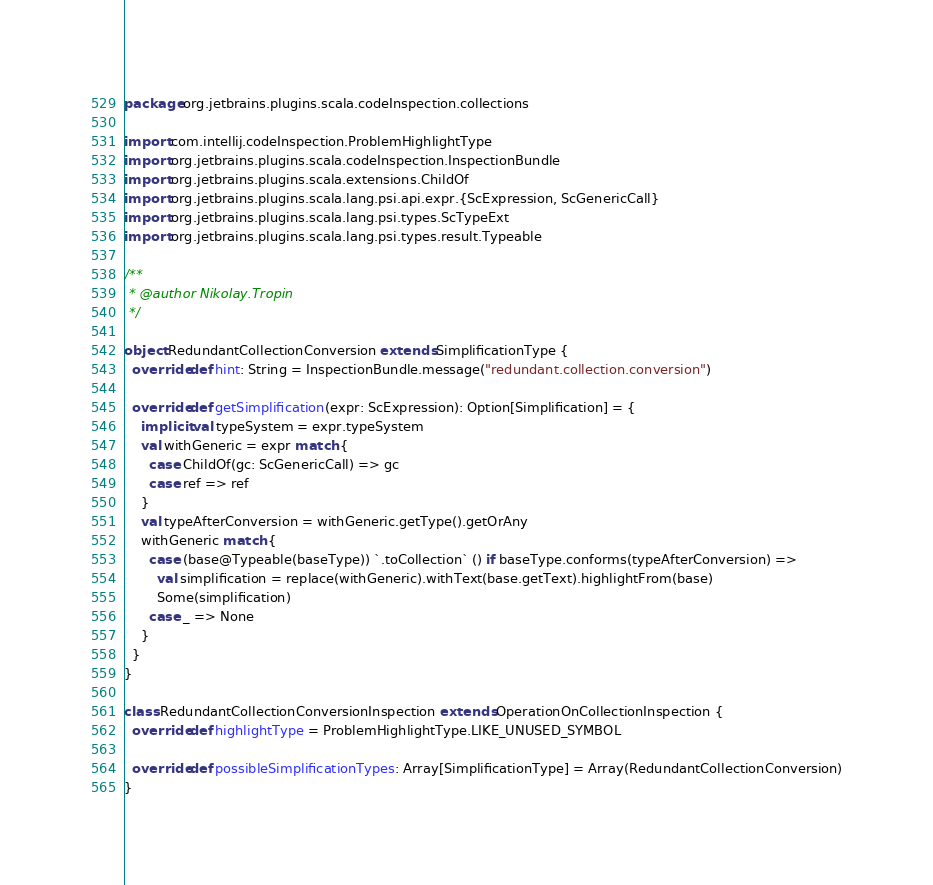Convert code to text. <code><loc_0><loc_0><loc_500><loc_500><_Scala_>package org.jetbrains.plugins.scala.codeInspection.collections

import com.intellij.codeInspection.ProblemHighlightType
import org.jetbrains.plugins.scala.codeInspection.InspectionBundle
import org.jetbrains.plugins.scala.extensions.ChildOf
import org.jetbrains.plugins.scala.lang.psi.api.expr.{ScExpression, ScGenericCall}
import org.jetbrains.plugins.scala.lang.psi.types.ScTypeExt
import org.jetbrains.plugins.scala.lang.psi.types.result.Typeable

/**
 * @author Nikolay.Tropin
 */

object RedundantCollectionConversion extends SimplificationType {
  override def hint: String = InspectionBundle.message("redundant.collection.conversion")

  override def getSimplification(expr: ScExpression): Option[Simplification] = {
    implicit val typeSystem = expr.typeSystem
    val withGeneric = expr match {
      case ChildOf(gc: ScGenericCall) => gc
      case ref => ref
    }
    val typeAfterConversion = withGeneric.getType().getOrAny
    withGeneric match {
      case (base@Typeable(baseType)) `.toCollection` () if baseType.conforms(typeAfterConversion) =>
        val simplification = replace(withGeneric).withText(base.getText).highlightFrom(base)
        Some(simplification)
      case _ => None
    }
  }
}

class RedundantCollectionConversionInspection extends OperationOnCollectionInspection {
  override def highlightType = ProblemHighlightType.LIKE_UNUSED_SYMBOL

  override def possibleSimplificationTypes: Array[SimplificationType] = Array(RedundantCollectionConversion)
}
</code> 